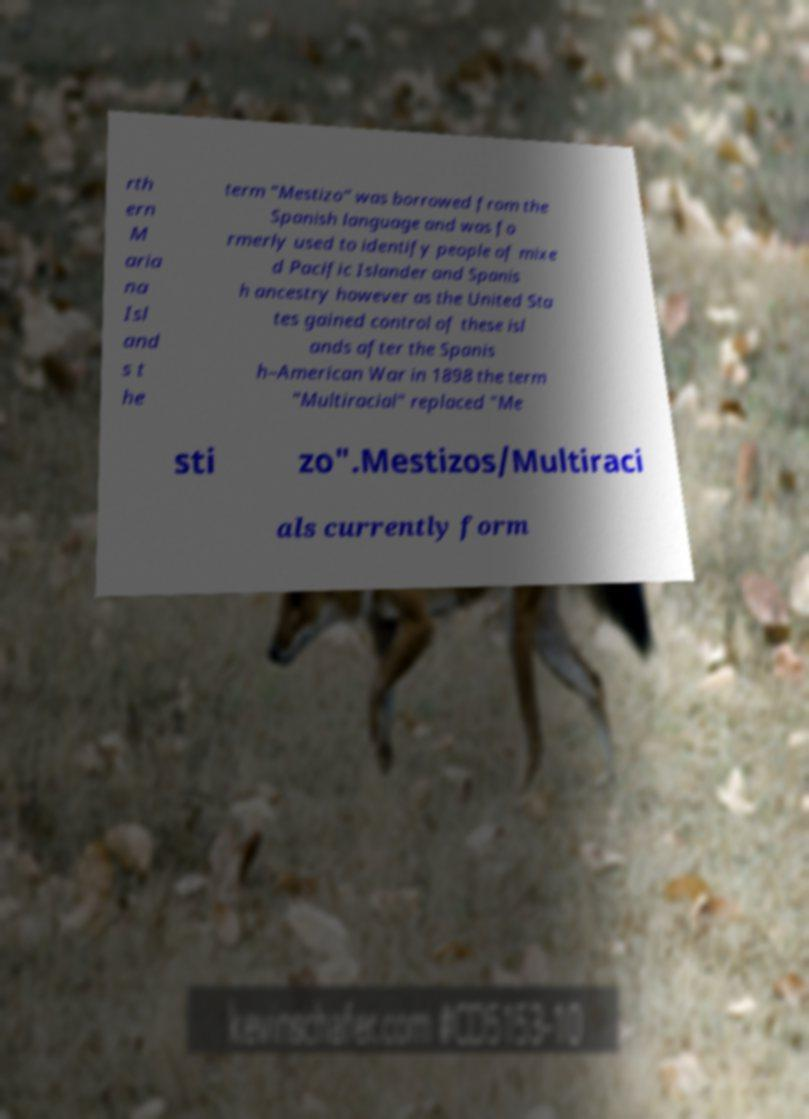Can you accurately transcribe the text from the provided image for me? rth ern M aria na Isl and s t he term "Mestizo" was borrowed from the Spanish language and was fo rmerly used to identify people of mixe d Pacific Islander and Spanis h ancestry however as the United Sta tes gained control of these isl ands after the Spanis h–American War in 1898 the term "Multiracial" replaced "Me sti zo".Mestizos/Multiraci als currently form 